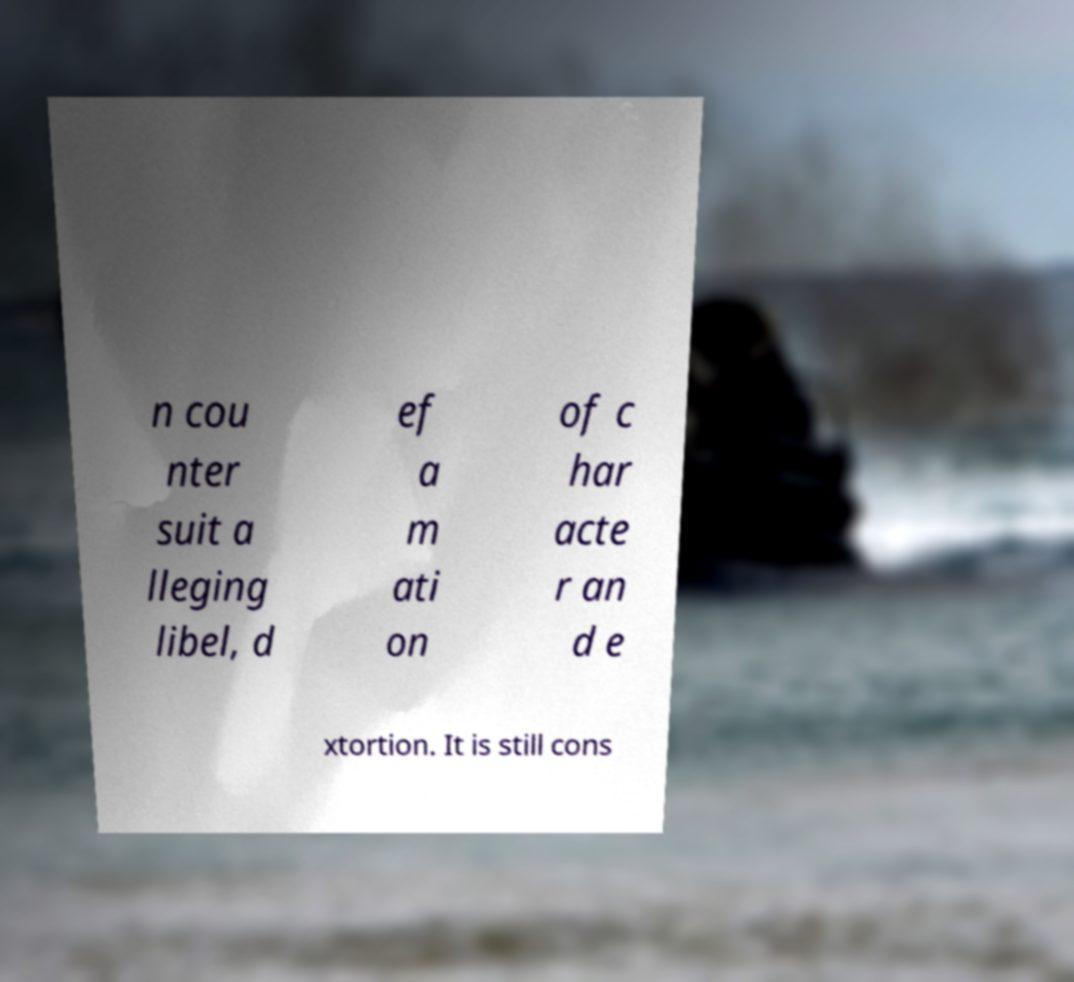Please identify and transcribe the text found in this image. n cou nter suit a lleging libel, d ef a m ati on of c har acte r an d e xtortion. It is still cons 